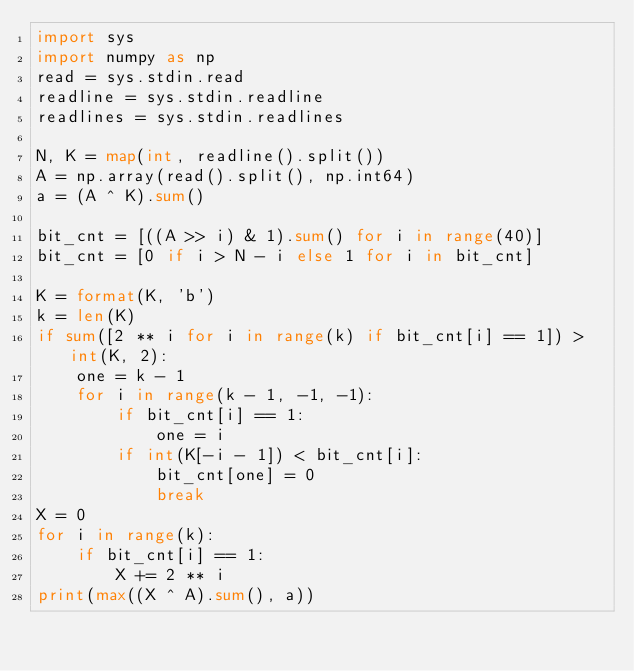Convert code to text. <code><loc_0><loc_0><loc_500><loc_500><_Python_>import sys
import numpy as np
read = sys.stdin.read
readline = sys.stdin.readline
readlines = sys.stdin.readlines

N, K = map(int, readline().split())
A = np.array(read().split(), np.int64)
a = (A ^ K).sum()

bit_cnt = [((A >> i) & 1).sum() for i in range(40)]
bit_cnt = [0 if i > N - i else 1 for i in bit_cnt]

K = format(K, 'b')
k = len(K)
if sum([2 ** i for i in range(k) if bit_cnt[i] == 1]) > int(K, 2):
    one = k - 1
    for i in range(k - 1, -1, -1):
        if bit_cnt[i] == 1:
            one = i
        if int(K[-i - 1]) < bit_cnt[i]:
            bit_cnt[one] = 0
            break
X = 0
for i in range(k):
    if bit_cnt[i] == 1:
        X += 2 ** i
print(max((X ^ A).sum(), a))</code> 